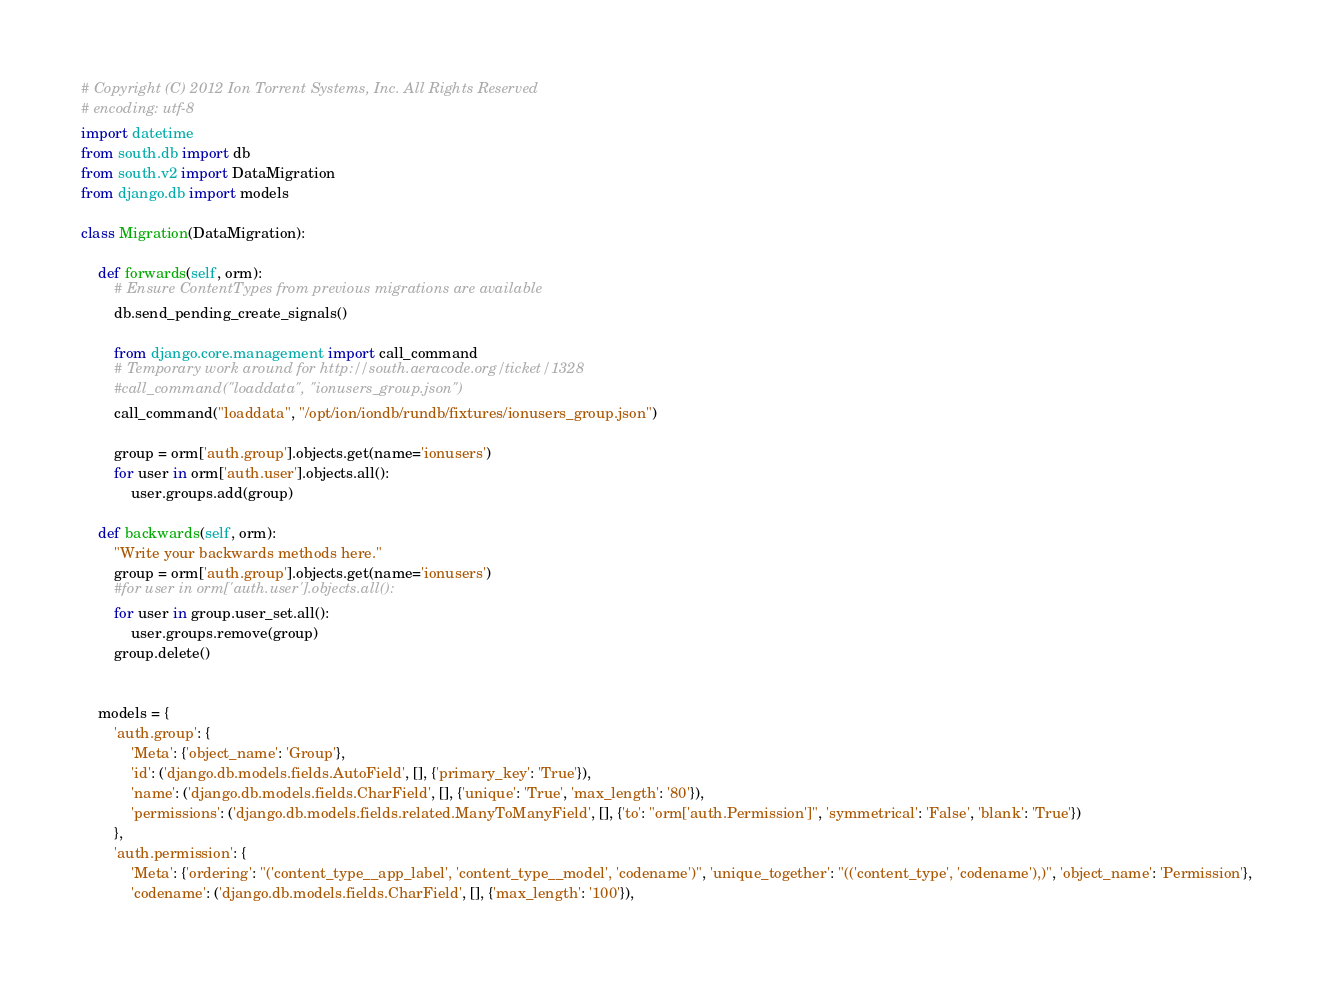Convert code to text. <code><loc_0><loc_0><loc_500><loc_500><_Python_># Copyright (C) 2012 Ion Torrent Systems, Inc. All Rights Reserved
# encoding: utf-8
import datetime
from south.db import db
from south.v2 import DataMigration
from django.db import models

class Migration(DataMigration):

    def forwards(self, orm):
        # Ensure ContentTypes from previous migrations are available
        db.send_pending_create_signals()

        from django.core.management import call_command
        # Temporary work around for http://south.aeracode.org/ticket/1328
        #call_command("loaddata", "ionusers_group.json")
        call_command("loaddata", "/opt/ion/iondb/rundb/fixtures/ionusers_group.json")

        group = orm['auth.group'].objects.get(name='ionusers')
        for user in orm['auth.user'].objects.all():
            user.groups.add(group)

    def backwards(self, orm):
        "Write your backwards methods here."
        group = orm['auth.group'].objects.get(name='ionusers')
        #for user in orm['auth.user'].objects.all():
        for user in group.user_set.all():
            user.groups.remove(group)
        group.delete()


    models = {
        'auth.group': {
            'Meta': {'object_name': 'Group'},
            'id': ('django.db.models.fields.AutoField', [], {'primary_key': 'True'}),
            'name': ('django.db.models.fields.CharField', [], {'unique': 'True', 'max_length': '80'}),
            'permissions': ('django.db.models.fields.related.ManyToManyField', [], {'to': "orm['auth.Permission']", 'symmetrical': 'False', 'blank': 'True'})
        },
        'auth.permission': {
            'Meta': {'ordering': "('content_type__app_label', 'content_type__model', 'codename')", 'unique_together': "(('content_type', 'codename'),)", 'object_name': 'Permission'},
            'codename': ('django.db.models.fields.CharField', [], {'max_length': '100'}),</code> 